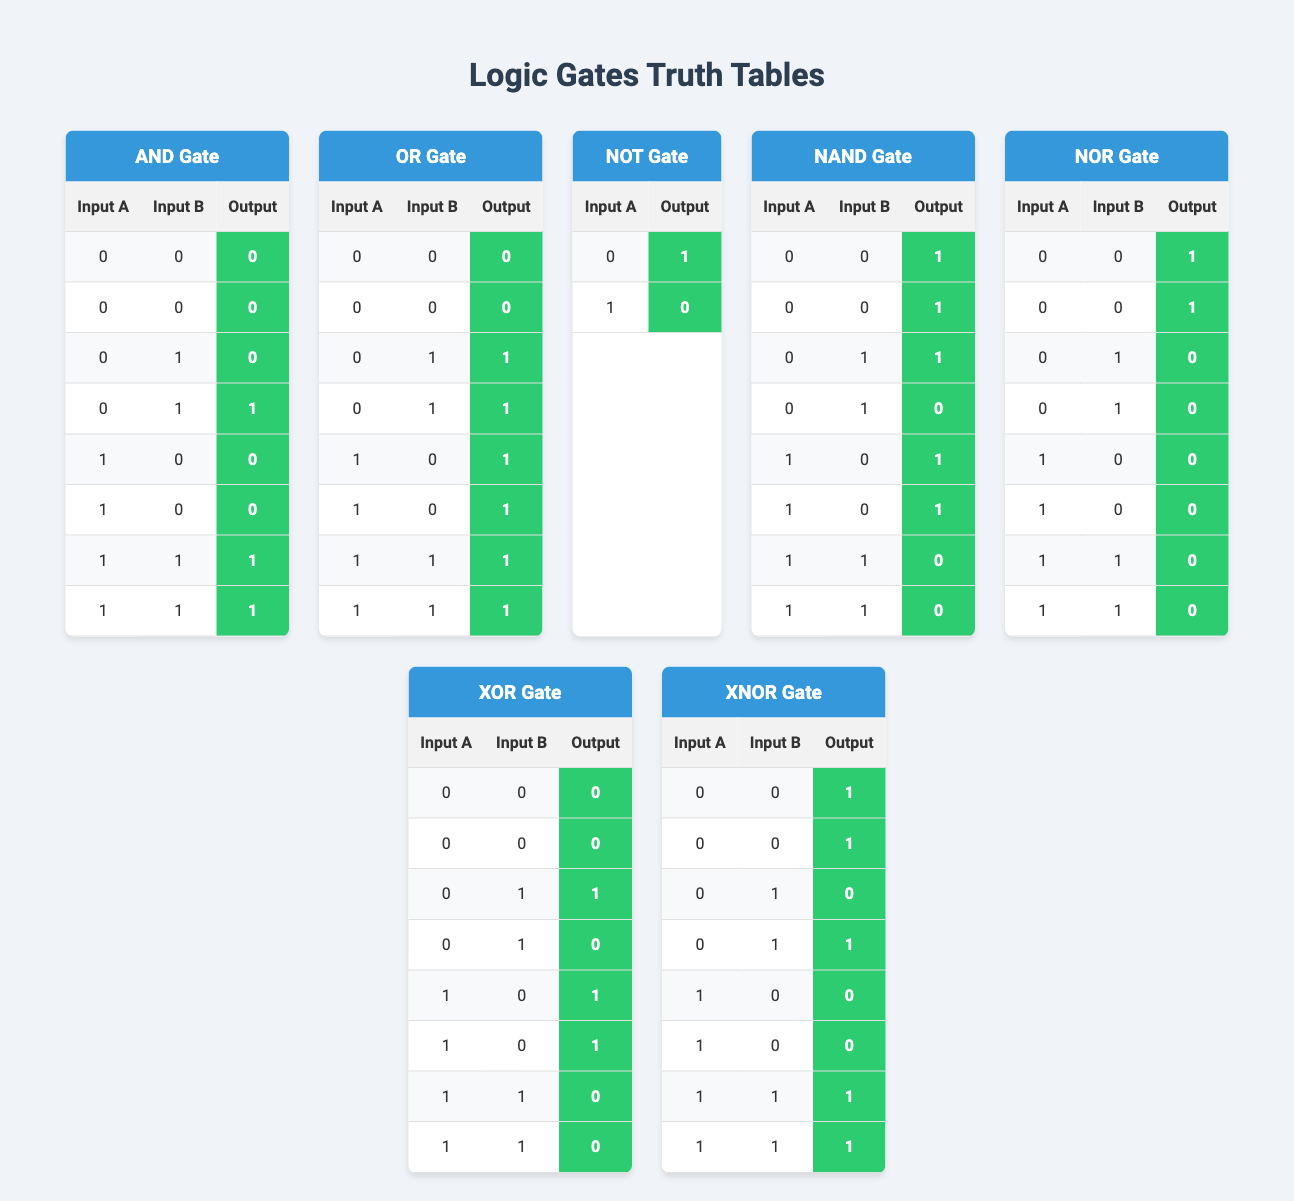What is the output of the AND gate when both inputs are 0? From the truth table for the AND gate, when Input A is 0 and Input B is also 0, the corresponding output is 0.
Answer: 0 For which inputs does the OR gate produce an output of 1? By examining the OR gate truth table, the output is 1 for the following input combinations: (0,1), (1,0), and (1,1).
Answer: (0,1), (1,0), (1,1) Does the NOT gate ever output 1? The NOT gate outputs 1 when Input A is 0, which is reflected in the truth table. So yes, the NOT gate does output 1.
Answer: Yes What is the output of the NAND gate when both inputs are 1? Checking the NAND gate truth table, when both Input A and Input B are 1, the output is 0.
Answer: 0 When does the XOR gate output 0? The XOR gate outputs 0 when both inputs are the same, which occurs for input combinations of (0,0) and (1,1) according to the truth table.
Answer: (0,0), (1,1) What is the difference between the numbers of 1s in the outputs for the AND and NAND gates? The AND gate outputs 1 two times (for inputs (1,1) and (0,1)), while the NAND gate outputs 1 six times. The difference is 6 - 2 = 4.
Answer: 4 How many times does the NOR gate output a value of 1? From the truth table of the NOR gate, it outputs a value of 1 two times (both when inputs are (0,0)).
Answer: 2 Is the output of the XNOR gate always the same as the output of the XOR gate? No, the output of the XNOR gate is the opposite of the XOR gate; they are never the same for the same inputs.
Answer: No How many unique output values does the NOT gate produce? The NOT gate produces 2 unique output values (0 and 1) based on its truth table.
Answer: 2 